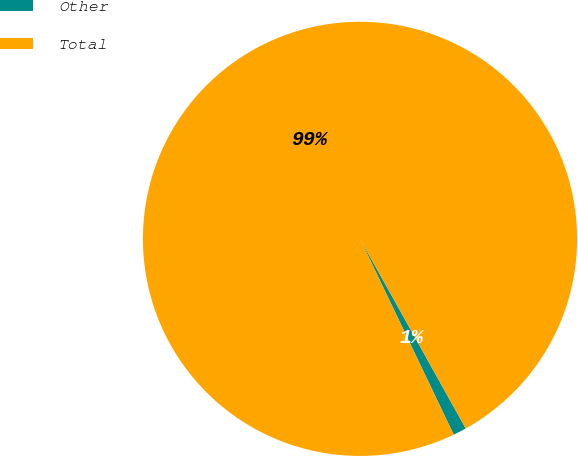Convert chart to OTSL. <chart><loc_0><loc_0><loc_500><loc_500><pie_chart><fcel>Other<fcel>Total<nl><fcel>0.99%<fcel>99.01%<nl></chart> 